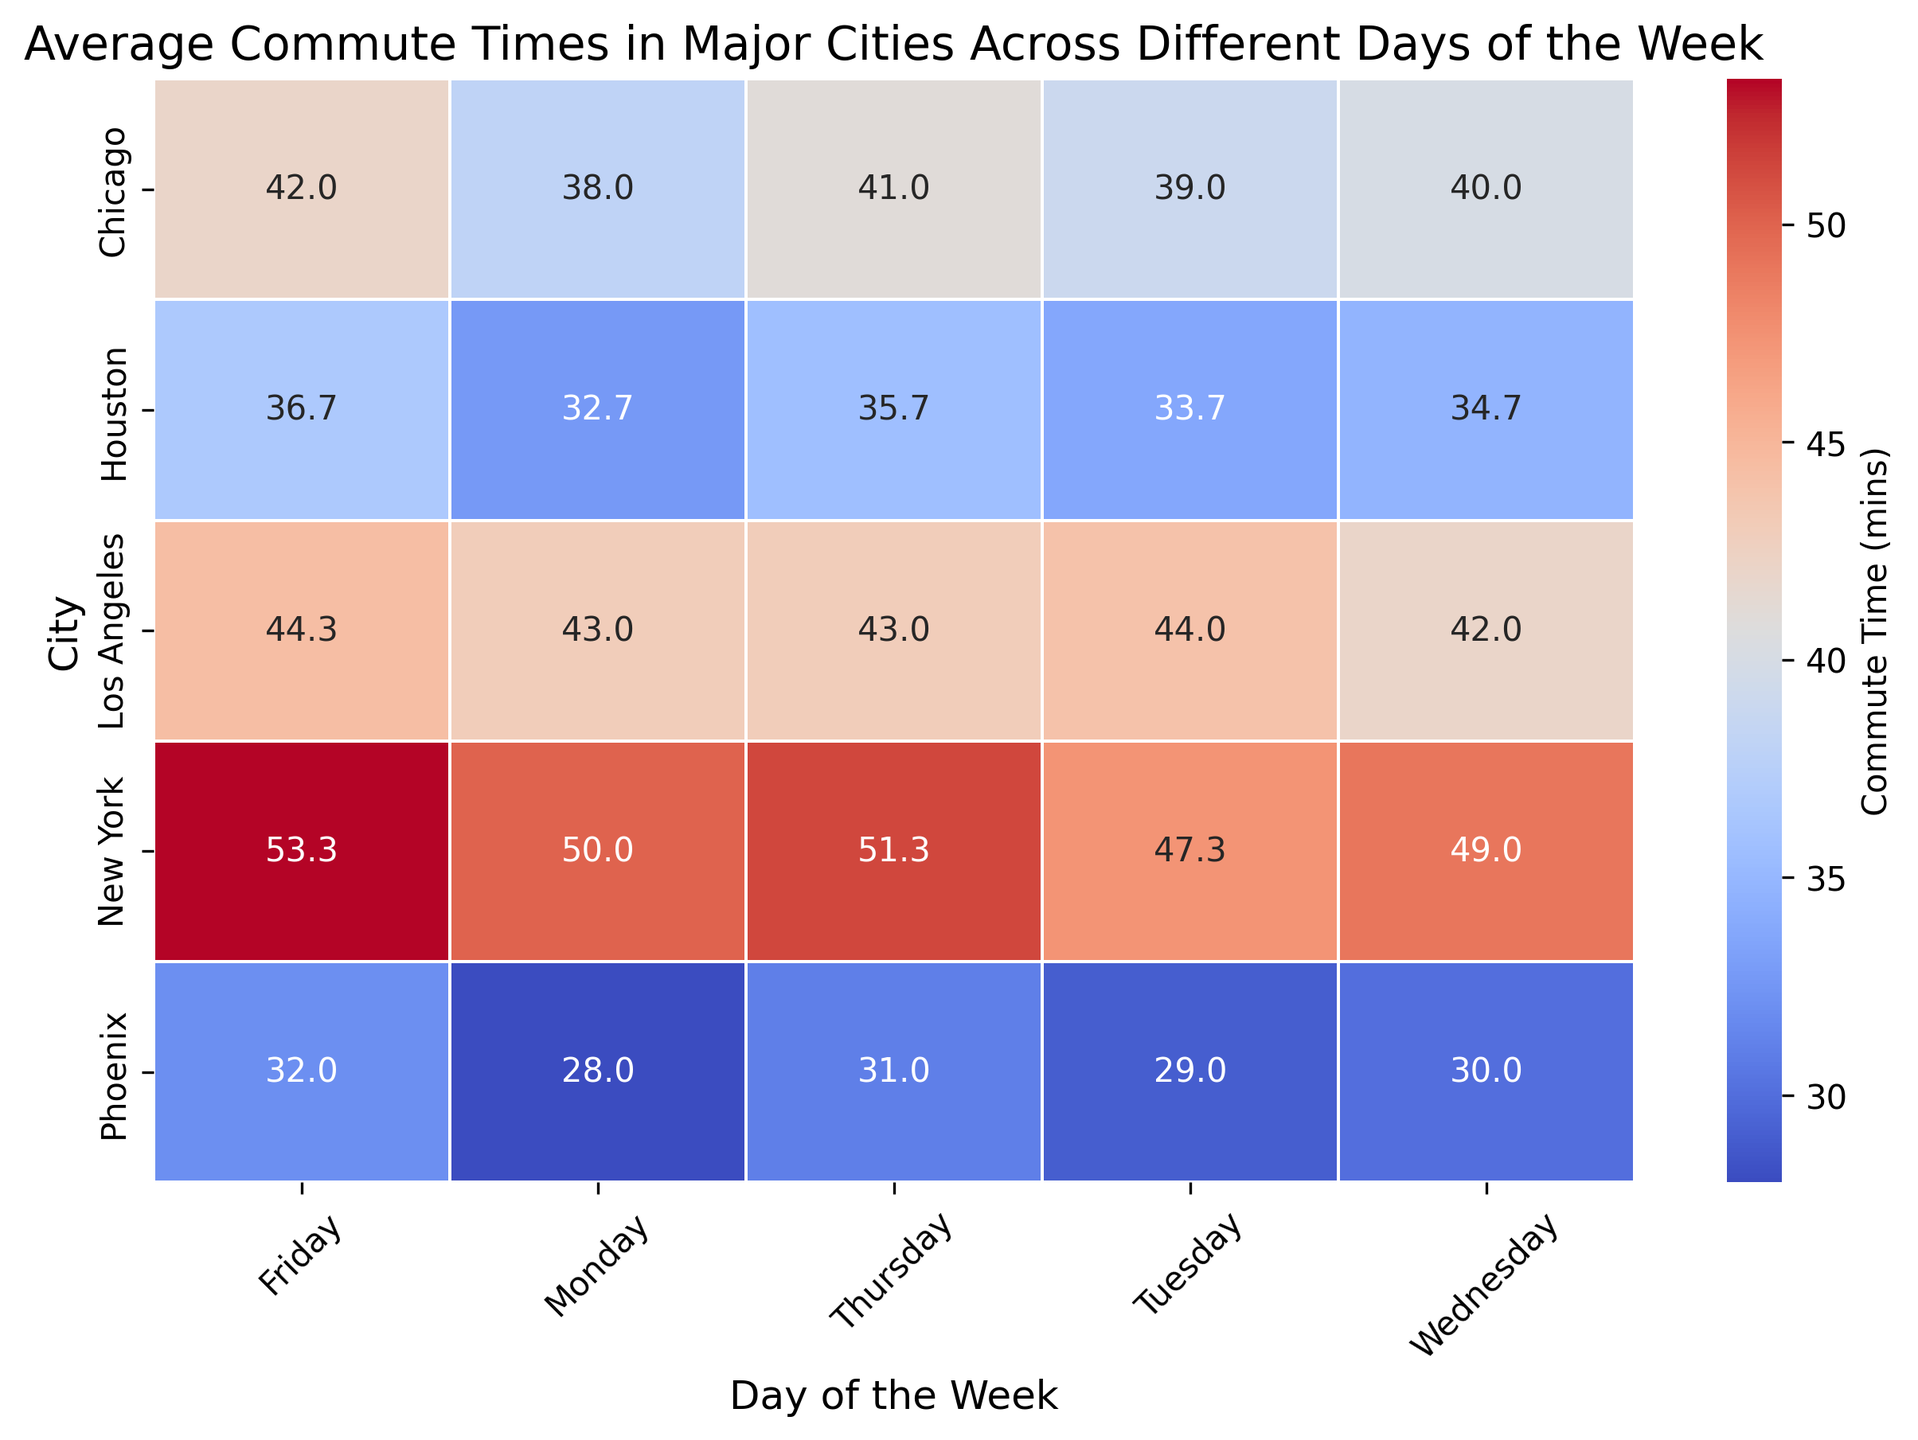What's the average commute time for New York on Thursday? To find this, look at the cell corresponding to New York and Thursday in the heatmap.
Answer: 51.3 mins Which city has the lowest average commute time on Wednesday? Identify the cells corresponding to Wednesday and check which one has the lowest value. Confirm that Phoenix has the lowest value.
Answer: Phoenix On which day does Chicago have the highest average commute time? Locate the row for Chicago and then compare the values across the different days. Friday has the highest value.
Answer: Friday Which city's commute time changes the most between Monday and Tuesday? Calculate the difference between Monday and Tuesday for each city and find the maximum change.
Answer: New York Is the average commute time for Los Angeles on Fridays higher or lower than on Tuesdays? Compare the value for Los Angeles on Tuesday and Friday to determine if it is higher or lower.
Answer: Higher Which day shows the most consistent commute times across all cities? Compare the variances or check the color intensity for all days across cities. Wednesday appears most consistent.
Answer: Wednesday How does Houston's average commute time on Monday compare to Phoenix's? Check the values for Houston and Phoenix on Monday and compare them.
Answer: Houston is higher Between New York and Chicago, which city has a higher average commute time on Monday? Identify the values for New York and Chicago on Monday and compare them.
Answer: New York What is the difference in average commute time between Los Angeles and New York on Thursday? Subtract the average commute time of Los Angeles on Thursday from that of New York's.
Answer: 7.7 mins 